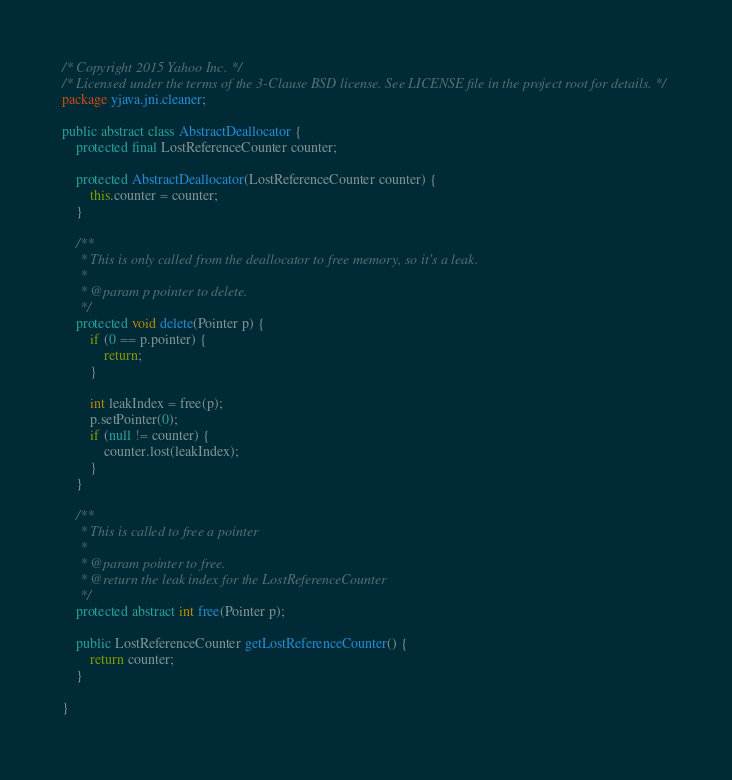<code> <loc_0><loc_0><loc_500><loc_500><_Java_>/* Copyright 2015 Yahoo Inc. */
/* Licensed under the terms of the 3-Clause BSD license. See LICENSE file in the project root for details. */
package yjava.jni.cleaner;

public abstract class AbstractDeallocator {
    protected final LostReferenceCounter counter;

    protected AbstractDeallocator(LostReferenceCounter counter) {
        this.counter = counter;
    }

    /**
     * This is only called from the deallocator to free memory, so it's a leak.
     * 
     * @param p pointer to delete.
     */
    protected void delete(Pointer p) {
        if (0 == p.pointer) {
            return;
        }

        int leakIndex = free(p);
        p.setPointer(0);
        if (null != counter) {
            counter.lost(leakIndex);
        }
    }

    /**
     * This is called to free a pointer
     * 
     * @param pointer to free.
     * @return the leak index for the LostReferenceCounter
     */
    protected abstract int free(Pointer p);

    public LostReferenceCounter getLostReferenceCounter() {
        return counter;
    }

}
</code> 